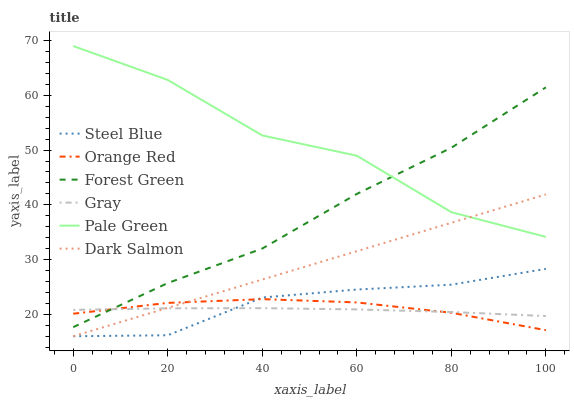Does Gray have the minimum area under the curve?
Answer yes or no. Yes. Does Pale Green have the maximum area under the curve?
Answer yes or no. Yes. Does Dark Salmon have the minimum area under the curve?
Answer yes or no. No. Does Dark Salmon have the maximum area under the curve?
Answer yes or no. No. Is Dark Salmon the smoothest?
Answer yes or no. Yes. Is Pale Green the roughest?
Answer yes or no. Yes. Is Steel Blue the smoothest?
Answer yes or no. No. Is Steel Blue the roughest?
Answer yes or no. No. Does Dark Salmon have the lowest value?
Answer yes or no. Yes. Does Forest Green have the lowest value?
Answer yes or no. No. Does Pale Green have the highest value?
Answer yes or no. Yes. Does Dark Salmon have the highest value?
Answer yes or no. No. Is Dark Salmon less than Forest Green?
Answer yes or no. Yes. Is Pale Green greater than Gray?
Answer yes or no. Yes. Does Dark Salmon intersect Pale Green?
Answer yes or no. Yes. Is Dark Salmon less than Pale Green?
Answer yes or no. No. Is Dark Salmon greater than Pale Green?
Answer yes or no. No. Does Dark Salmon intersect Forest Green?
Answer yes or no. No. 